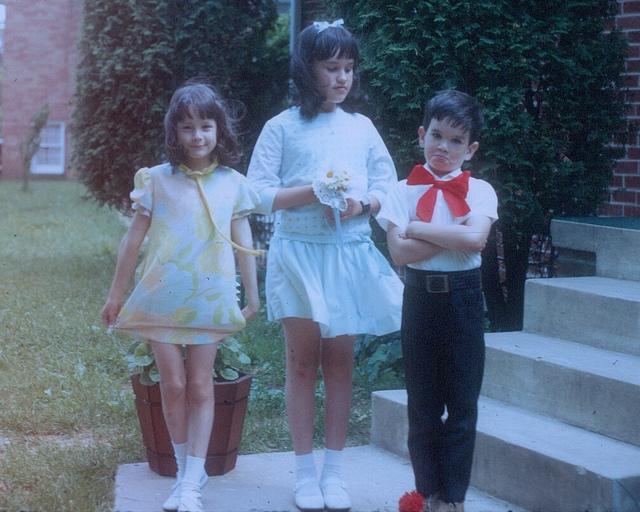How many of the kids are wearing dresses?
Give a very brief answer. 2. How many steps are there?
Give a very brief answer. 4. How many people can you see?
Give a very brief answer. 3. How many vases are reflected in the mirror?
Give a very brief answer. 0. 